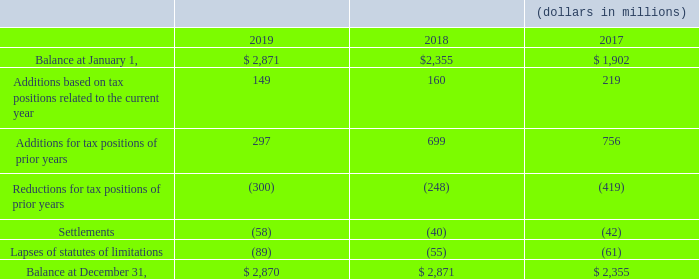A reconciliation of the beginning and ending balance of unrecognized tax benefits is as follows:
Included in the total unrecognized tax benefits at December 31, 2019, 2018 and 2017 is $2.4 billion, $2.3 billion and $1.9 billion, respectively, that if recognized, would favorably affect the effective income tax rate.
What was the amount that would favorably affect the effective income tax rate if included in 2019? $2.4 billion. What was the amount that would favorably affect the effective income tax rate if included in 2018? $2.3 billion. What was the amount that would favorably affect the effective income tax rate if included in 2017? $1.9 billion. What was the change in the Additions based on tax positions related to the current year from 2018 to 2019?
Answer scale should be: million. 149 - 160
Answer: -11. What was the average Additions for tax positions of prior years for 2017-2019?
Answer scale should be: million. (297 + 699 + 756) / 3
Answer: 584. What was the average settlements for 2017-2019?
Answer scale should be: million. -(58 + 40 + 42) / 3
Answer: -46.67. 